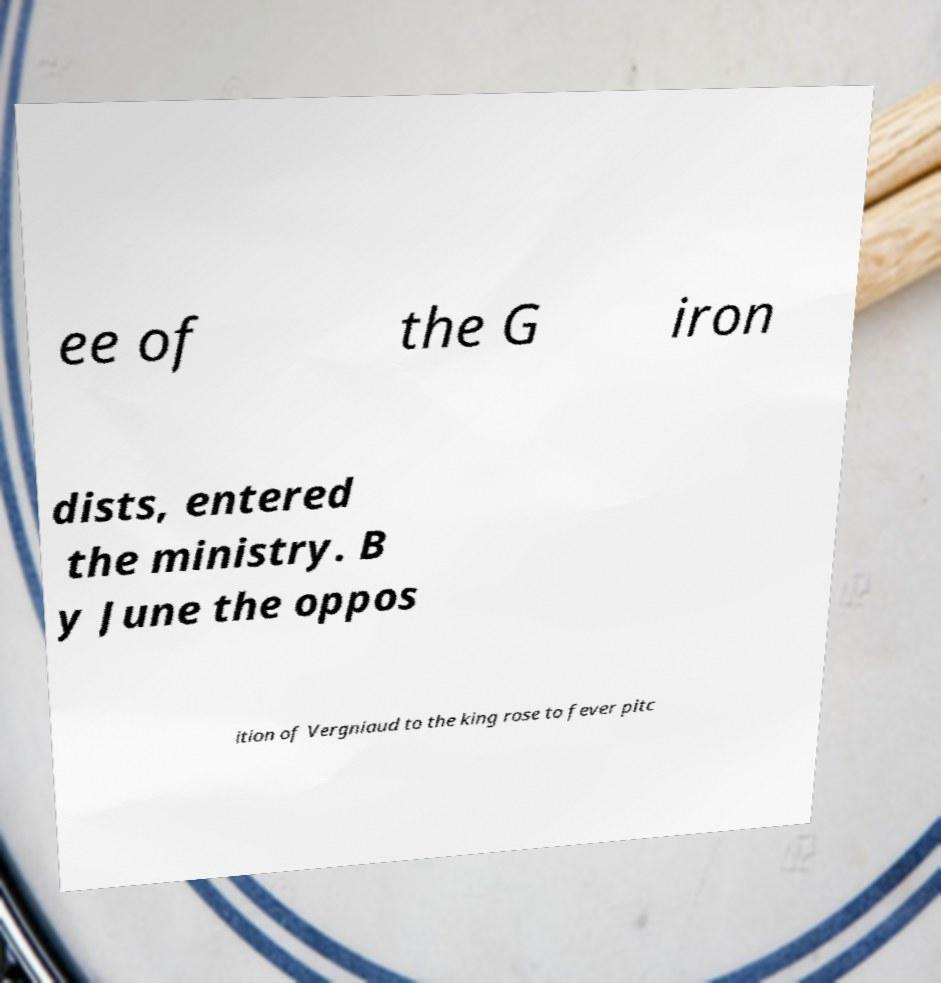Please read and relay the text visible in this image. What does it say? ee of the G iron dists, entered the ministry. B y June the oppos ition of Vergniaud to the king rose to fever pitc 